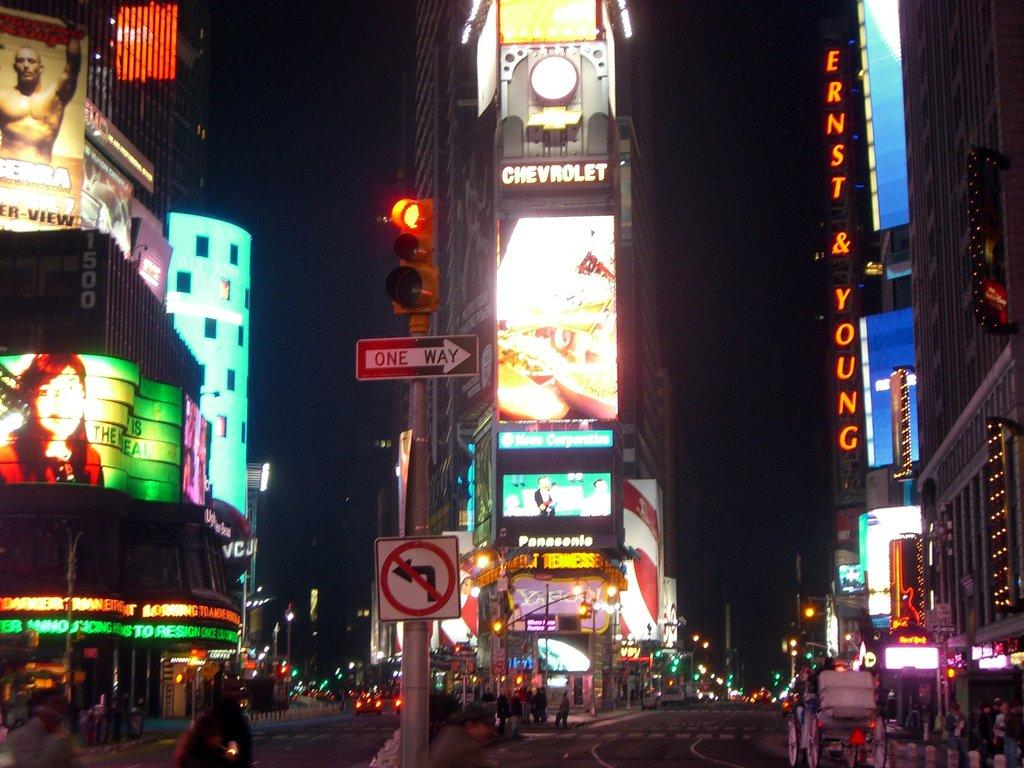<image>
Give a short and clear explanation of the subsequent image. The middle of a city square that says chevrolet 